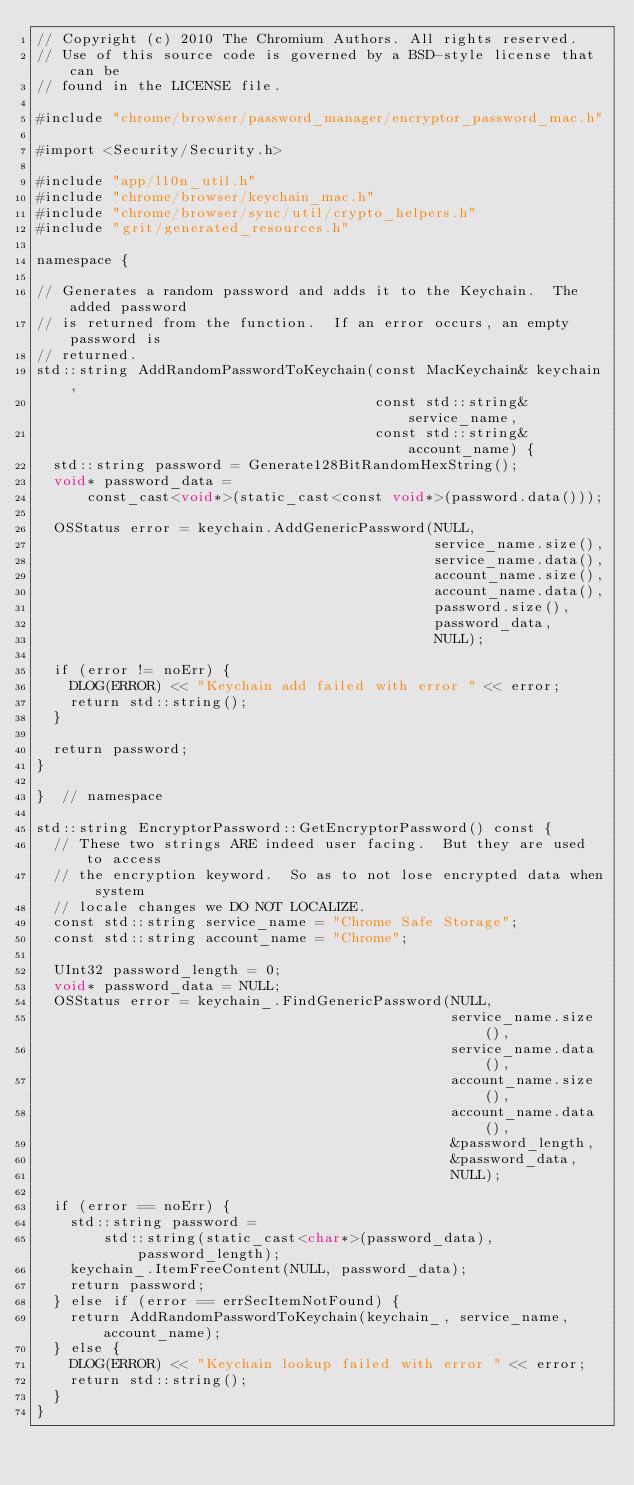Convert code to text. <code><loc_0><loc_0><loc_500><loc_500><_ObjectiveC_>// Copyright (c) 2010 The Chromium Authors. All rights reserved.
// Use of this source code is governed by a BSD-style license that can be
// found in the LICENSE file.

#include "chrome/browser/password_manager/encryptor_password_mac.h"

#import <Security/Security.h>

#include "app/l10n_util.h"
#include "chrome/browser/keychain_mac.h"
#include "chrome/browser/sync/util/crypto_helpers.h"
#include "grit/generated_resources.h"

namespace {

// Generates a random password and adds it to the Keychain.  The added password
// is returned from the function.  If an error occurs, an empty password is
// returned.
std::string AddRandomPasswordToKeychain(const MacKeychain& keychain,
                                        const std::string& service_name,
                                        const std::string& account_name) {
  std::string password = Generate128BitRandomHexString();
  void* password_data =
      const_cast<void*>(static_cast<const void*>(password.data()));

  OSStatus error = keychain.AddGenericPassword(NULL,
                                               service_name.size(),
                                               service_name.data(),
                                               account_name.size(),
                                               account_name.data(),
                                               password.size(),
                                               password_data,
                                               NULL);

  if (error != noErr) {
    DLOG(ERROR) << "Keychain add failed with error " << error;
    return std::string();
  }

  return password;
}

}  // namespace

std::string EncryptorPassword::GetEncryptorPassword() const {
  // These two strings ARE indeed user facing.  But they are used to access
  // the encryption keyword.  So as to not lose encrypted data when system
  // locale changes we DO NOT LOCALIZE.
  const std::string service_name = "Chrome Safe Storage";
  const std::string account_name = "Chrome";

  UInt32 password_length = 0;
  void* password_data = NULL;
  OSStatus error = keychain_.FindGenericPassword(NULL,
                                                 service_name.size(),
                                                 service_name.data(),
                                                 account_name.size(),
                                                 account_name.data(),
                                                 &password_length,
                                                 &password_data,
                                                 NULL);

  if (error == noErr) {
    std::string password =
        std::string(static_cast<char*>(password_data), password_length);
    keychain_.ItemFreeContent(NULL, password_data);
    return password;
  } else if (error == errSecItemNotFound) {
    return AddRandomPasswordToKeychain(keychain_, service_name, account_name);
  } else {
    DLOG(ERROR) << "Keychain lookup failed with error " << error;
    return std::string();
  }
}


</code> 